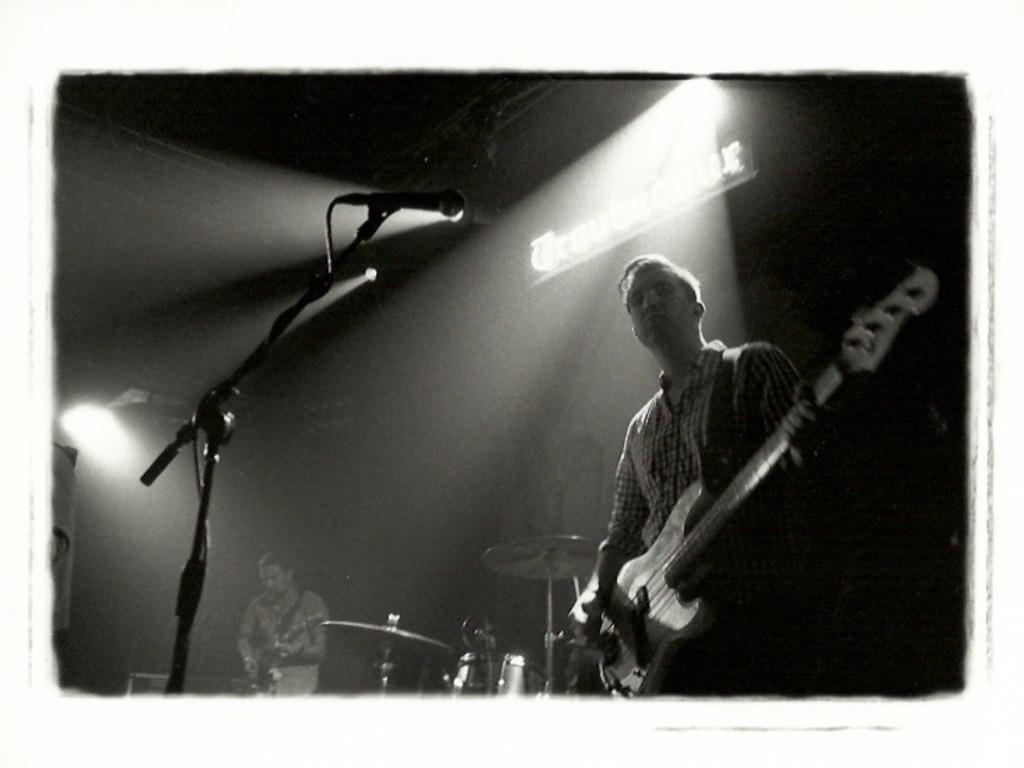How many people are in the image? There are two persons in the image. What are the two persons doing? The two persons are playing guitar. What object is present for amplifying sound? There is a microphone (mike) in the image. What other objects are related to music in the image? There are musical instruments in the image. What can be seen providing illumination in the image? There is a light in the image. What type of zinc is present in the image? There is no zinc present in the image. Where is the lunchroom located in the image? There is no lunchroom present in the image. 